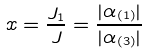<formula> <loc_0><loc_0><loc_500><loc_500>x = \frac { J _ { 1 } } { J } = \frac { | \alpha _ { ( 1 ) } | } { | \alpha _ { ( 3 ) } | }</formula> 